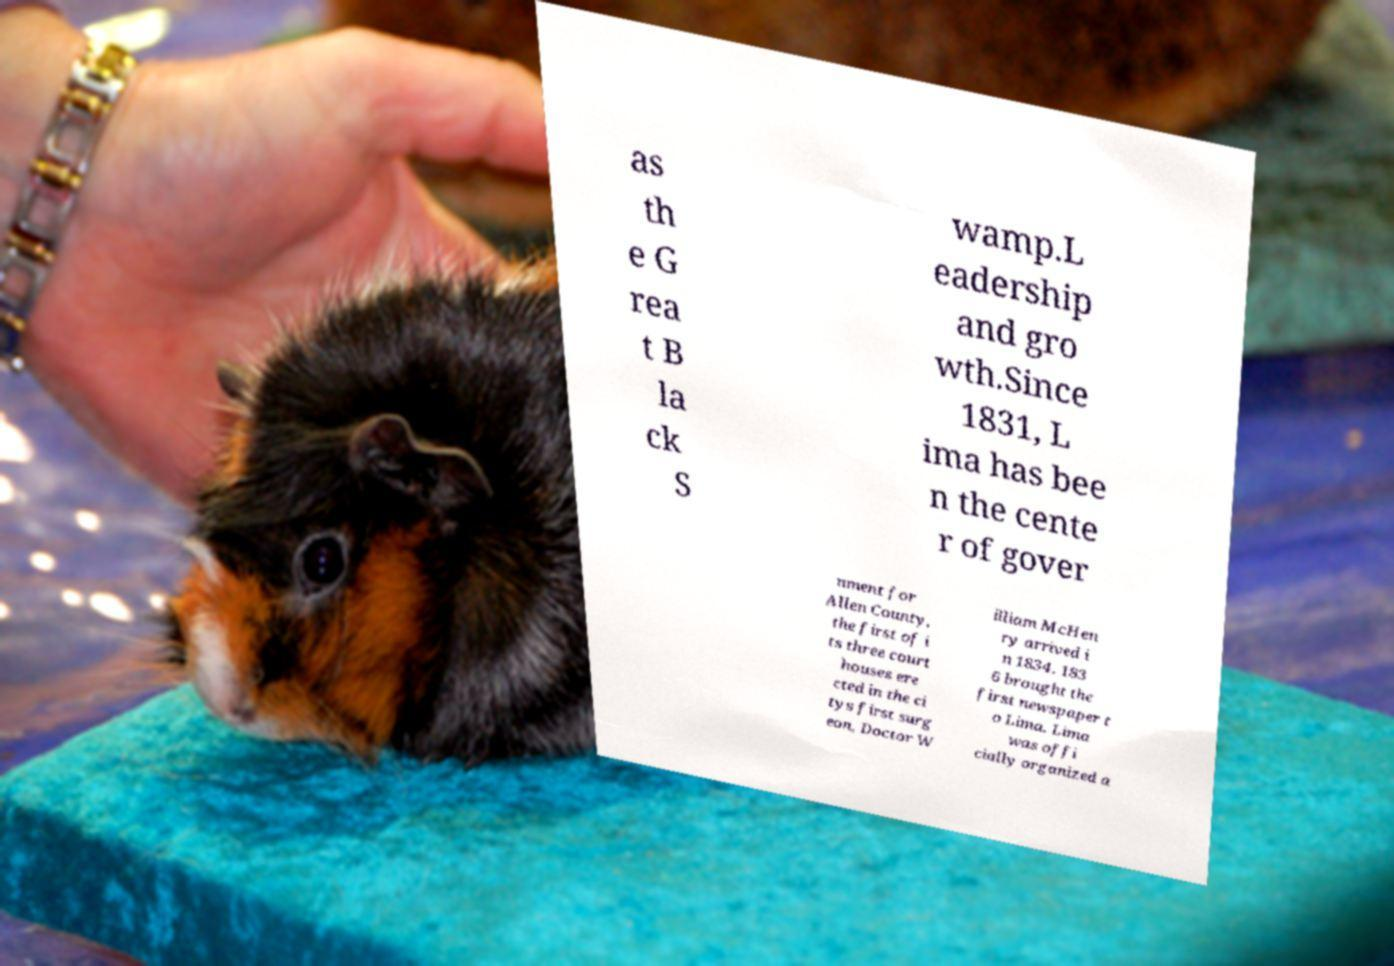Could you extract and type out the text from this image? as th e G rea t B la ck S wamp.L eadership and gro wth.Since 1831, L ima has bee n the cente r of gover nment for Allen County, the first of i ts three court houses ere cted in the ci tys first surg eon, Doctor W illiam McHen ry arrived i n 1834. 183 6 brought the first newspaper t o Lima. Lima was offi cially organized a 